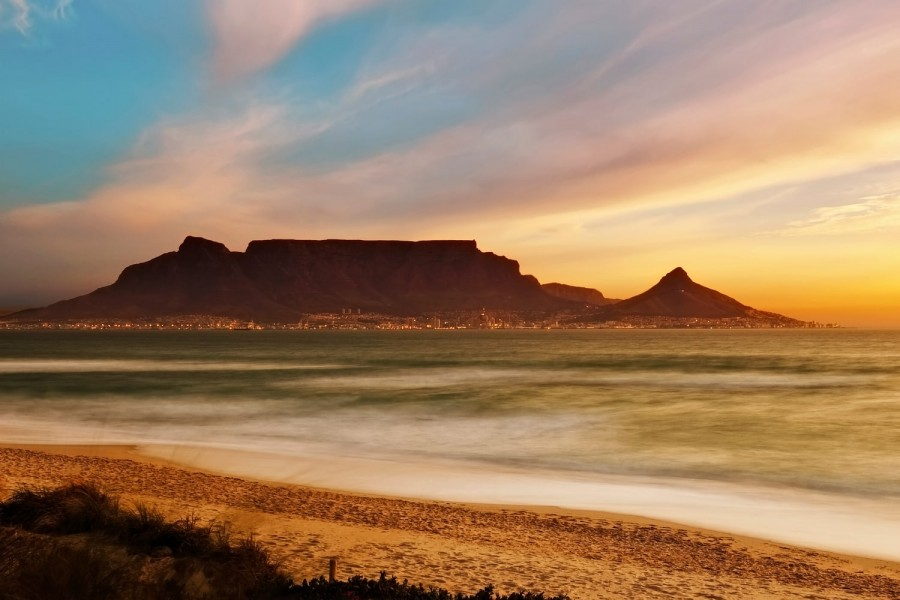Imagine if this beach had a mystical creature. Describe what it would be and its interaction with the scene! Imagine a majestic, shimmering creature known as the 'Sea Luminaire,' a blend of myth and bioluminescence. This creature, with scales twinkling like city lights and wings made of translucent, iridescent material, emerges gracefully from the ocean. As it takes flight, droplets of water cascade off its wings, catching the vibrant hues of the sunset and refracting them into a dazzling array of colors. The Sea Luminaire circles around Table Mountain, its glow blending with the urban lights, creating a surreal dance of light and color across the sky. Visitors on the beach gaze in awe, their footprints marking the sand as they witness this extraordinary blend of natural beauty and fantastical wonder. 